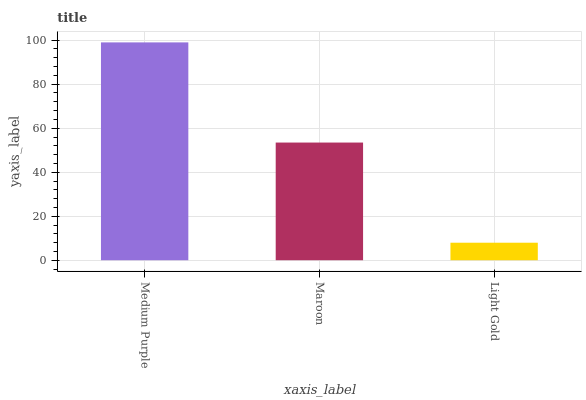Is Light Gold the minimum?
Answer yes or no. Yes. Is Medium Purple the maximum?
Answer yes or no. Yes. Is Maroon the minimum?
Answer yes or no. No. Is Maroon the maximum?
Answer yes or no. No. Is Medium Purple greater than Maroon?
Answer yes or no. Yes. Is Maroon less than Medium Purple?
Answer yes or no. Yes. Is Maroon greater than Medium Purple?
Answer yes or no. No. Is Medium Purple less than Maroon?
Answer yes or no. No. Is Maroon the high median?
Answer yes or no. Yes. Is Maroon the low median?
Answer yes or no. Yes. Is Medium Purple the high median?
Answer yes or no. No. Is Light Gold the low median?
Answer yes or no. No. 